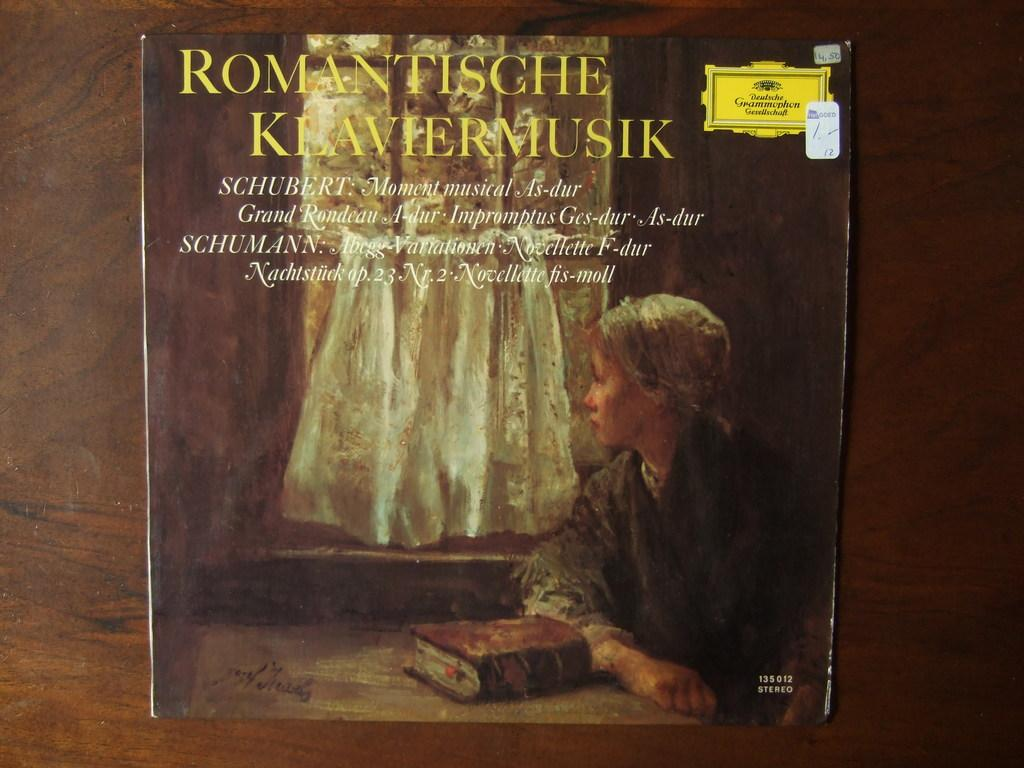<image>
Summarize the visual content of the image. A record album containing the music of Schubert and Schumann is titled Romantische Klaviermusik. 